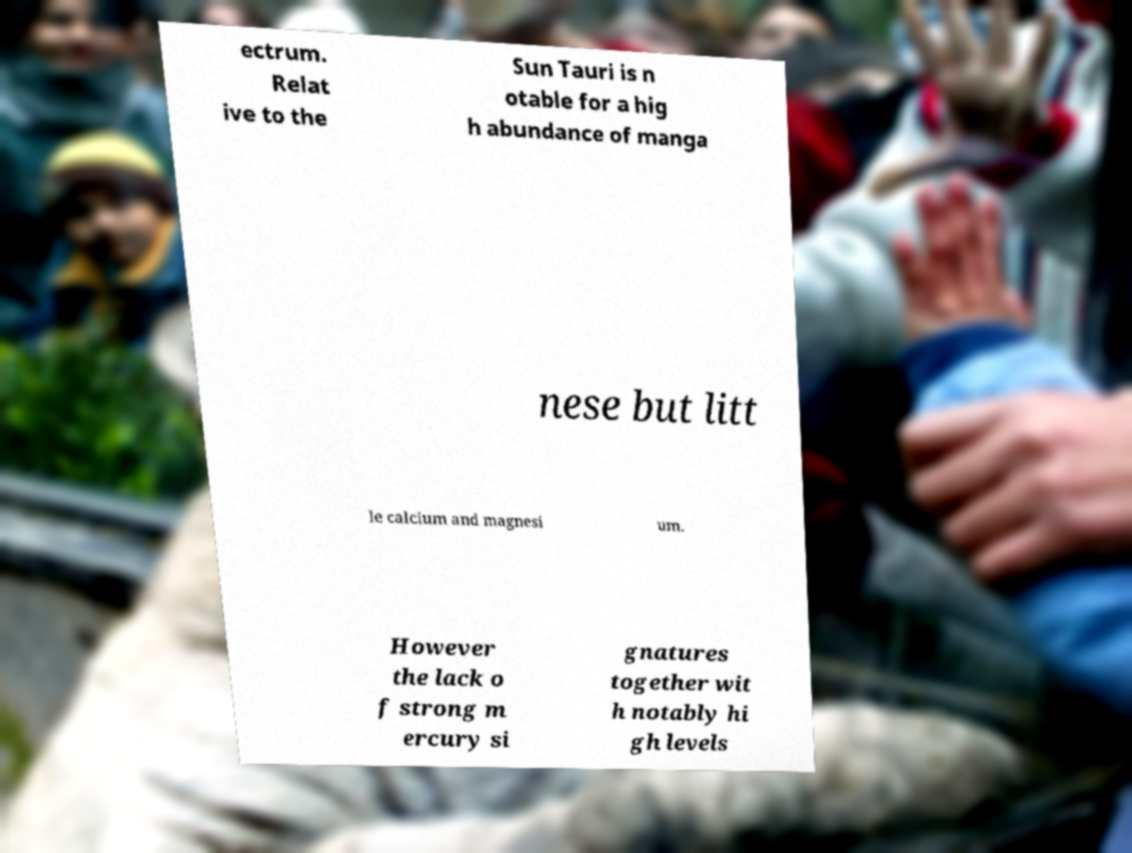Could you assist in decoding the text presented in this image and type it out clearly? ectrum. Relat ive to the Sun Tauri is n otable for a hig h abundance of manga nese but litt le calcium and magnesi um. However the lack o f strong m ercury si gnatures together wit h notably hi gh levels 